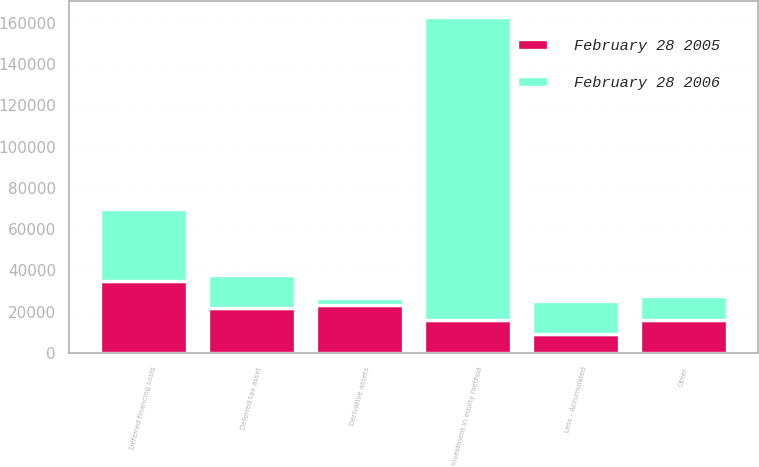Convert chart. <chart><loc_0><loc_0><loc_500><loc_500><stacked_bar_chart><ecel><fcel>Investment in equity method<fcel>Deferred financing costs<fcel>Deferred tax asset<fcel>Derivative assets<fcel>Other<fcel>Less - Accumulated<nl><fcel>February 28 2006<fcel>146639<fcel>34827<fcel>15824<fcel>3714<fcel>11557<fcel>15623<nl><fcel>February 28 2005<fcel>15880<fcel>34827<fcel>21808<fcel>23147<fcel>15880<fcel>9392<nl></chart> 